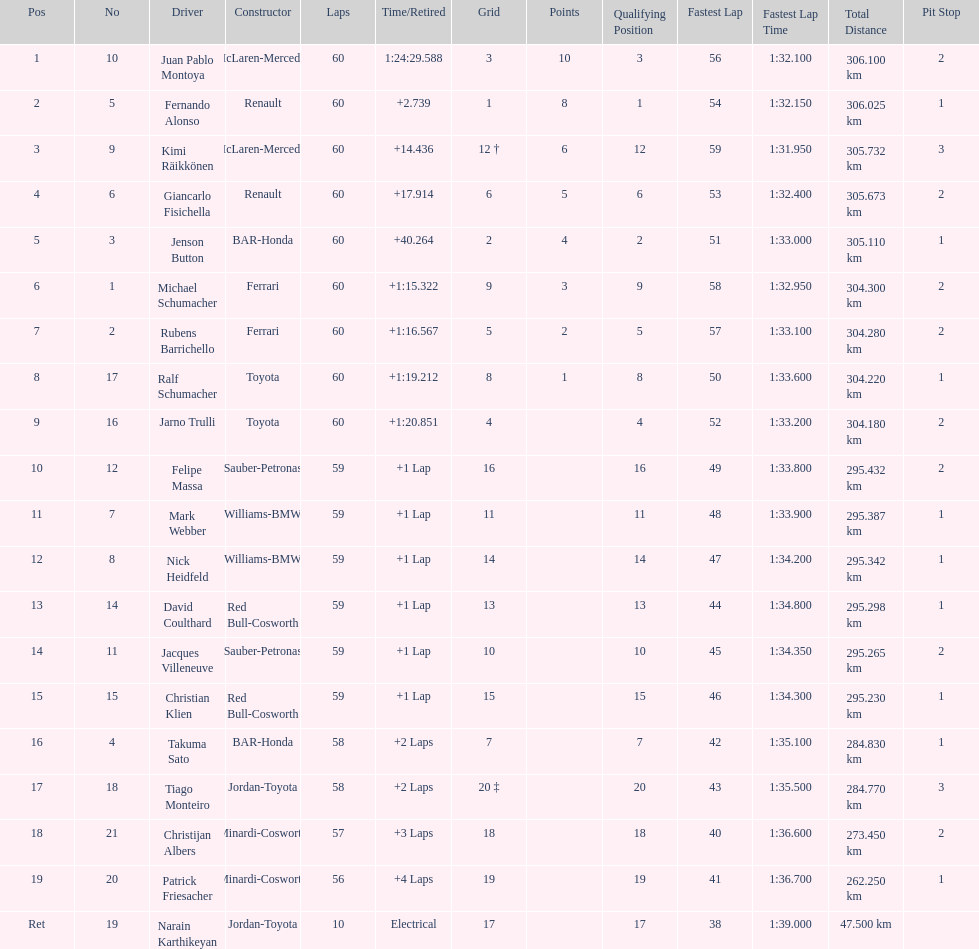Which driver came after giancarlo fisichella? Jenson Button. 